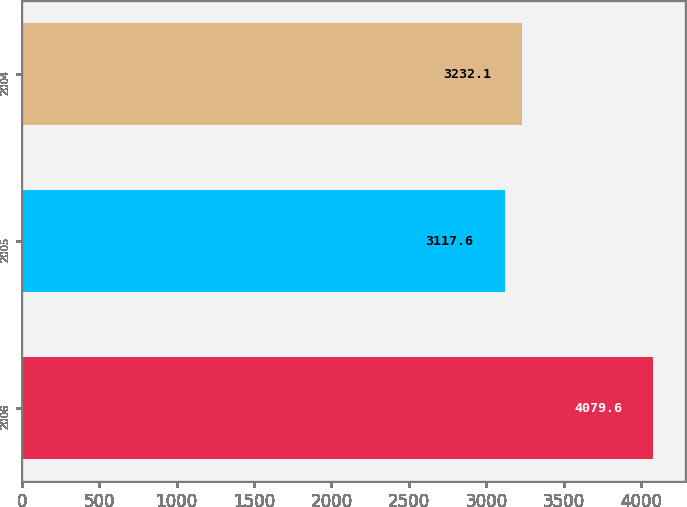Convert chart to OTSL. <chart><loc_0><loc_0><loc_500><loc_500><bar_chart><fcel>2006<fcel>2005<fcel>2004<nl><fcel>4079.6<fcel>3117.6<fcel>3232.1<nl></chart> 